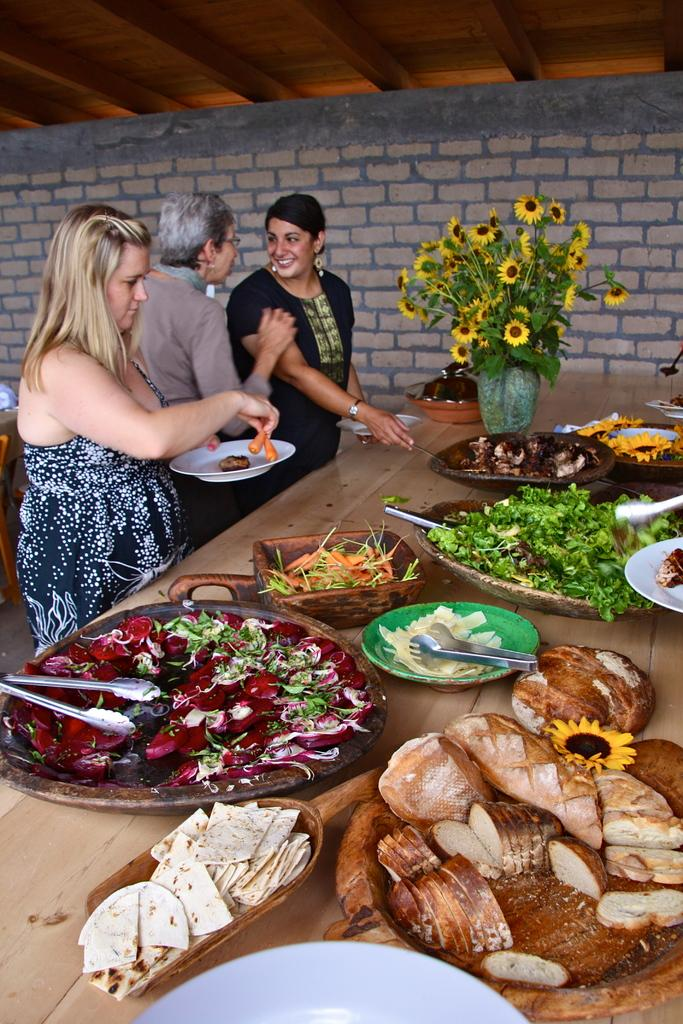What can be seen on the table in the image? There are food items on the table in the image. How many people are present in the image? There are three persons in the image. What decorative item is on the table? There is a flower vase on the table. What can be seen in the background of the image? There is a wall visible in the background. What type of quiver is being used by one of the persons in the image? There is no quiver present in the image; it features food items on a table and three persons. What language are the persons speaking in the image? The image does not provide any information about the language being spoken by the persons. 